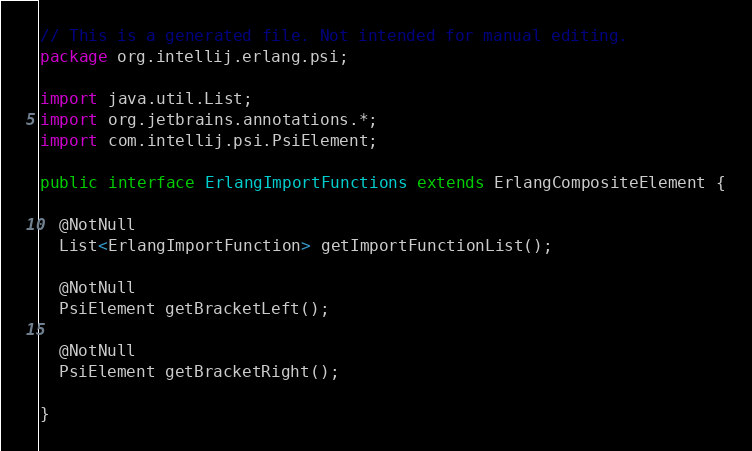Convert code to text. <code><loc_0><loc_0><loc_500><loc_500><_Java_>// This is a generated file. Not intended for manual editing.
package org.intellij.erlang.psi;

import java.util.List;
import org.jetbrains.annotations.*;
import com.intellij.psi.PsiElement;

public interface ErlangImportFunctions extends ErlangCompositeElement {

  @NotNull
  List<ErlangImportFunction> getImportFunctionList();

  @NotNull
  PsiElement getBracketLeft();

  @NotNull
  PsiElement getBracketRight();

}
</code> 